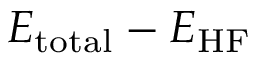<formula> <loc_0><loc_0><loc_500><loc_500>E _ { t o t a l } - E _ { H F }</formula> 